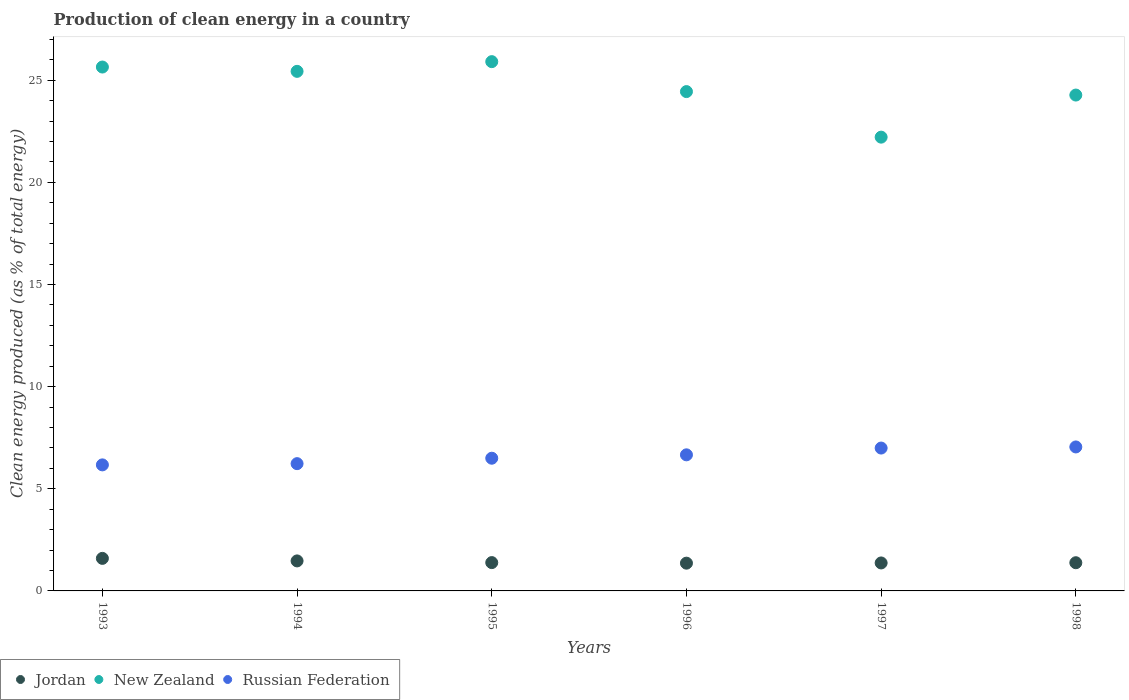What is the percentage of clean energy produced in New Zealand in 1994?
Give a very brief answer. 25.44. Across all years, what is the maximum percentage of clean energy produced in Jordan?
Provide a succinct answer. 1.59. Across all years, what is the minimum percentage of clean energy produced in Jordan?
Your response must be concise. 1.36. In which year was the percentage of clean energy produced in New Zealand minimum?
Give a very brief answer. 1997. What is the total percentage of clean energy produced in Jordan in the graph?
Your answer should be very brief. 8.56. What is the difference between the percentage of clean energy produced in Russian Federation in 1995 and that in 1997?
Provide a short and direct response. -0.5. What is the difference between the percentage of clean energy produced in New Zealand in 1998 and the percentage of clean energy produced in Jordan in 1997?
Your answer should be very brief. 22.91. What is the average percentage of clean energy produced in Russian Federation per year?
Offer a very short reply. 6.6. In the year 1998, what is the difference between the percentage of clean energy produced in Jordan and percentage of clean energy produced in Russian Federation?
Make the answer very short. -5.67. What is the ratio of the percentage of clean energy produced in Jordan in 1993 to that in 1998?
Your answer should be compact. 1.15. Is the difference between the percentage of clean energy produced in Jordan in 1993 and 1994 greater than the difference between the percentage of clean energy produced in Russian Federation in 1993 and 1994?
Make the answer very short. Yes. What is the difference between the highest and the second highest percentage of clean energy produced in New Zealand?
Your response must be concise. 0.26. What is the difference between the highest and the lowest percentage of clean energy produced in Jordan?
Make the answer very short. 0.23. Is the sum of the percentage of clean energy produced in New Zealand in 1994 and 1997 greater than the maximum percentage of clean energy produced in Jordan across all years?
Provide a short and direct response. Yes. Is it the case that in every year, the sum of the percentage of clean energy produced in New Zealand and percentage of clean energy produced in Jordan  is greater than the percentage of clean energy produced in Russian Federation?
Provide a short and direct response. Yes. Is the percentage of clean energy produced in New Zealand strictly less than the percentage of clean energy produced in Russian Federation over the years?
Provide a succinct answer. No. How many dotlines are there?
Make the answer very short. 3. Where does the legend appear in the graph?
Give a very brief answer. Bottom left. How are the legend labels stacked?
Ensure brevity in your answer.  Horizontal. What is the title of the graph?
Make the answer very short. Production of clean energy in a country. What is the label or title of the X-axis?
Provide a short and direct response. Years. What is the label or title of the Y-axis?
Make the answer very short. Clean energy produced (as % of total energy). What is the Clean energy produced (as % of total energy) of Jordan in 1993?
Your answer should be compact. 1.59. What is the Clean energy produced (as % of total energy) of New Zealand in 1993?
Ensure brevity in your answer.  25.65. What is the Clean energy produced (as % of total energy) in Russian Federation in 1993?
Give a very brief answer. 6.17. What is the Clean energy produced (as % of total energy) in Jordan in 1994?
Offer a very short reply. 1.47. What is the Clean energy produced (as % of total energy) in New Zealand in 1994?
Ensure brevity in your answer.  25.44. What is the Clean energy produced (as % of total energy) in Russian Federation in 1994?
Provide a short and direct response. 6.23. What is the Clean energy produced (as % of total energy) of Jordan in 1995?
Provide a short and direct response. 1.39. What is the Clean energy produced (as % of total energy) of New Zealand in 1995?
Provide a short and direct response. 25.91. What is the Clean energy produced (as % of total energy) of Russian Federation in 1995?
Provide a succinct answer. 6.5. What is the Clean energy produced (as % of total energy) of Jordan in 1996?
Your answer should be compact. 1.36. What is the Clean energy produced (as % of total energy) in New Zealand in 1996?
Provide a succinct answer. 24.45. What is the Clean energy produced (as % of total energy) of Russian Federation in 1996?
Give a very brief answer. 6.66. What is the Clean energy produced (as % of total energy) of Jordan in 1997?
Your answer should be very brief. 1.37. What is the Clean energy produced (as % of total energy) in New Zealand in 1997?
Your answer should be very brief. 22.22. What is the Clean energy produced (as % of total energy) in Russian Federation in 1997?
Provide a succinct answer. 6.99. What is the Clean energy produced (as % of total energy) in Jordan in 1998?
Offer a very short reply. 1.38. What is the Clean energy produced (as % of total energy) of New Zealand in 1998?
Your response must be concise. 24.28. What is the Clean energy produced (as % of total energy) in Russian Federation in 1998?
Provide a short and direct response. 7.05. Across all years, what is the maximum Clean energy produced (as % of total energy) of Jordan?
Provide a succinct answer. 1.59. Across all years, what is the maximum Clean energy produced (as % of total energy) in New Zealand?
Your answer should be compact. 25.91. Across all years, what is the maximum Clean energy produced (as % of total energy) of Russian Federation?
Ensure brevity in your answer.  7.05. Across all years, what is the minimum Clean energy produced (as % of total energy) of Jordan?
Provide a succinct answer. 1.36. Across all years, what is the minimum Clean energy produced (as % of total energy) in New Zealand?
Your response must be concise. 22.22. Across all years, what is the minimum Clean energy produced (as % of total energy) of Russian Federation?
Make the answer very short. 6.17. What is the total Clean energy produced (as % of total energy) in Jordan in the graph?
Keep it short and to the point. 8.56. What is the total Clean energy produced (as % of total energy) of New Zealand in the graph?
Provide a short and direct response. 147.93. What is the total Clean energy produced (as % of total energy) of Russian Federation in the graph?
Keep it short and to the point. 39.6. What is the difference between the Clean energy produced (as % of total energy) of Jordan in 1993 and that in 1994?
Provide a short and direct response. 0.12. What is the difference between the Clean energy produced (as % of total energy) of New Zealand in 1993 and that in 1994?
Your response must be concise. 0.21. What is the difference between the Clean energy produced (as % of total energy) of Russian Federation in 1993 and that in 1994?
Ensure brevity in your answer.  -0.06. What is the difference between the Clean energy produced (as % of total energy) of Jordan in 1993 and that in 1995?
Ensure brevity in your answer.  0.21. What is the difference between the Clean energy produced (as % of total energy) of New Zealand in 1993 and that in 1995?
Keep it short and to the point. -0.26. What is the difference between the Clean energy produced (as % of total energy) of Russian Federation in 1993 and that in 1995?
Ensure brevity in your answer.  -0.33. What is the difference between the Clean energy produced (as % of total energy) in Jordan in 1993 and that in 1996?
Give a very brief answer. 0.23. What is the difference between the Clean energy produced (as % of total energy) in New Zealand in 1993 and that in 1996?
Ensure brevity in your answer.  1.2. What is the difference between the Clean energy produced (as % of total energy) in Russian Federation in 1993 and that in 1996?
Make the answer very short. -0.49. What is the difference between the Clean energy produced (as % of total energy) of Jordan in 1993 and that in 1997?
Provide a short and direct response. 0.22. What is the difference between the Clean energy produced (as % of total energy) of New Zealand in 1993 and that in 1997?
Ensure brevity in your answer.  3.43. What is the difference between the Clean energy produced (as % of total energy) of Russian Federation in 1993 and that in 1997?
Keep it short and to the point. -0.82. What is the difference between the Clean energy produced (as % of total energy) in Jordan in 1993 and that in 1998?
Your response must be concise. 0.21. What is the difference between the Clean energy produced (as % of total energy) in New Zealand in 1993 and that in 1998?
Your answer should be very brief. 1.37. What is the difference between the Clean energy produced (as % of total energy) in Russian Federation in 1993 and that in 1998?
Provide a succinct answer. -0.88. What is the difference between the Clean energy produced (as % of total energy) in Jordan in 1994 and that in 1995?
Offer a terse response. 0.08. What is the difference between the Clean energy produced (as % of total energy) of New Zealand in 1994 and that in 1995?
Give a very brief answer. -0.47. What is the difference between the Clean energy produced (as % of total energy) in Russian Federation in 1994 and that in 1995?
Provide a short and direct response. -0.27. What is the difference between the Clean energy produced (as % of total energy) in Jordan in 1994 and that in 1996?
Your response must be concise. 0.11. What is the difference between the Clean energy produced (as % of total energy) of Russian Federation in 1994 and that in 1996?
Offer a very short reply. -0.43. What is the difference between the Clean energy produced (as % of total energy) in New Zealand in 1994 and that in 1997?
Provide a short and direct response. 3.22. What is the difference between the Clean energy produced (as % of total energy) in Russian Federation in 1994 and that in 1997?
Ensure brevity in your answer.  -0.76. What is the difference between the Clean energy produced (as % of total energy) in Jordan in 1994 and that in 1998?
Your answer should be very brief. 0.09. What is the difference between the Clean energy produced (as % of total energy) in New Zealand in 1994 and that in 1998?
Keep it short and to the point. 1.16. What is the difference between the Clean energy produced (as % of total energy) in Russian Federation in 1994 and that in 1998?
Offer a terse response. -0.82. What is the difference between the Clean energy produced (as % of total energy) in Jordan in 1995 and that in 1996?
Keep it short and to the point. 0.03. What is the difference between the Clean energy produced (as % of total energy) of New Zealand in 1995 and that in 1996?
Your answer should be compact. 1.47. What is the difference between the Clean energy produced (as % of total energy) of Russian Federation in 1995 and that in 1996?
Your answer should be compact. -0.17. What is the difference between the Clean energy produced (as % of total energy) in Jordan in 1995 and that in 1997?
Give a very brief answer. 0.02. What is the difference between the Clean energy produced (as % of total energy) of New Zealand in 1995 and that in 1997?
Keep it short and to the point. 3.7. What is the difference between the Clean energy produced (as % of total energy) of Russian Federation in 1995 and that in 1997?
Offer a terse response. -0.5. What is the difference between the Clean energy produced (as % of total energy) in Jordan in 1995 and that in 1998?
Keep it short and to the point. 0.01. What is the difference between the Clean energy produced (as % of total energy) of New Zealand in 1995 and that in 1998?
Offer a very short reply. 1.64. What is the difference between the Clean energy produced (as % of total energy) in Russian Federation in 1995 and that in 1998?
Provide a succinct answer. -0.55. What is the difference between the Clean energy produced (as % of total energy) in Jordan in 1996 and that in 1997?
Make the answer very short. -0.01. What is the difference between the Clean energy produced (as % of total energy) in New Zealand in 1996 and that in 1997?
Make the answer very short. 2.23. What is the difference between the Clean energy produced (as % of total energy) of Russian Federation in 1996 and that in 1997?
Make the answer very short. -0.33. What is the difference between the Clean energy produced (as % of total energy) of Jordan in 1996 and that in 1998?
Provide a succinct answer. -0.02. What is the difference between the Clean energy produced (as % of total energy) in New Zealand in 1996 and that in 1998?
Your response must be concise. 0.17. What is the difference between the Clean energy produced (as % of total energy) of Russian Federation in 1996 and that in 1998?
Your response must be concise. -0.39. What is the difference between the Clean energy produced (as % of total energy) of Jordan in 1997 and that in 1998?
Your answer should be very brief. -0.01. What is the difference between the Clean energy produced (as % of total energy) of New Zealand in 1997 and that in 1998?
Ensure brevity in your answer.  -2.06. What is the difference between the Clean energy produced (as % of total energy) of Russian Federation in 1997 and that in 1998?
Your answer should be very brief. -0.05. What is the difference between the Clean energy produced (as % of total energy) of Jordan in 1993 and the Clean energy produced (as % of total energy) of New Zealand in 1994?
Keep it short and to the point. -23.84. What is the difference between the Clean energy produced (as % of total energy) in Jordan in 1993 and the Clean energy produced (as % of total energy) in Russian Federation in 1994?
Provide a short and direct response. -4.64. What is the difference between the Clean energy produced (as % of total energy) in New Zealand in 1993 and the Clean energy produced (as % of total energy) in Russian Federation in 1994?
Keep it short and to the point. 19.42. What is the difference between the Clean energy produced (as % of total energy) in Jordan in 1993 and the Clean energy produced (as % of total energy) in New Zealand in 1995?
Offer a terse response. -24.32. What is the difference between the Clean energy produced (as % of total energy) of Jordan in 1993 and the Clean energy produced (as % of total energy) of Russian Federation in 1995?
Give a very brief answer. -4.9. What is the difference between the Clean energy produced (as % of total energy) in New Zealand in 1993 and the Clean energy produced (as % of total energy) in Russian Federation in 1995?
Make the answer very short. 19.15. What is the difference between the Clean energy produced (as % of total energy) in Jordan in 1993 and the Clean energy produced (as % of total energy) in New Zealand in 1996?
Your answer should be very brief. -22.85. What is the difference between the Clean energy produced (as % of total energy) of Jordan in 1993 and the Clean energy produced (as % of total energy) of Russian Federation in 1996?
Give a very brief answer. -5.07. What is the difference between the Clean energy produced (as % of total energy) of New Zealand in 1993 and the Clean energy produced (as % of total energy) of Russian Federation in 1996?
Offer a very short reply. 18.99. What is the difference between the Clean energy produced (as % of total energy) of Jordan in 1993 and the Clean energy produced (as % of total energy) of New Zealand in 1997?
Make the answer very short. -20.62. What is the difference between the Clean energy produced (as % of total energy) of Jordan in 1993 and the Clean energy produced (as % of total energy) of Russian Federation in 1997?
Provide a short and direct response. -5.4. What is the difference between the Clean energy produced (as % of total energy) in New Zealand in 1993 and the Clean energy produced (as % of total energy) in Russian Federation in 1997?
Keep it short and to the point. 18.65. What is the difference between the Clean energy produced (as % of total energy) of Jordan in 1993 and the Clean energy produced (as % of total energy) of New Zealand in 1998?
Make the answer very short. -22.68. What is the difference between the Clean energy produced (as % of total energy) of Jordan in 1993 and the Clean energy produced (as % of total energy) of Russian Federation in 1998?
Your answer should be compact. -5.45. What is the difference between the Clean energy produced (as % of total energy) of New Zealand in 1993 and the Clean energy produced (as % of total energy) of Russian Federation in 1998?
Give a very brief answer. 18.6. What is the difference between the Clean energy produced (as % of total energy) of Jordan in 1994 and the Clean energy produced (as % of total energy) of New Zealand in 1995?
Your answer should be compact. -24.44. What is the difference between the Clean energy produced (as % of total energy) of Jordan in 1994 and the Clean energy produced (as % of total energy) of Russian Federation in 1995?
Provide a short and direct response. -5.03. What is the difference between the Clean energy produced (as % of total energy) of New Zealand in 1994 and the Clean energy produced (as % of total energy) of Russian Federation in 1995?
Provide a succinct answer. 18.94. What is the difference between the Clean energy produced (as % of total energy) of Jordan in 1994 and the Clean energy produced (as % of total energy) of New Zealand in 1996?
Keep it short and to the point. -22.98. What is the difference between the Clean energy produced (as % of total energy) of Jordan in 1994 and the Clean energy produced (as % of total energy) of Russian Federation in 1996?
Give a very brief answer. -5.19. What is the difference between the Clean energy produced (as % of total energy) in New Zealand in 1994 and the Clean energy produced (as % of total energy) in Russian Federation in 1996?
Offer a very short reply. 18.77. What is the difference between the Clean energy produced (as % of total energy) in Jordan in 1994 and the Clean energy produced (as % of total energy) in New Zealand in 1997?
Make the answer very short. -20.75. What is the difference between the Clean energy produced (as % of total energy) in Jordan in 1994 and the Clean energy produced (as % of total energy) in Russian Federation in 1997?
Give a very brief answer. -5.52. What is the difference between the Clean energy produced (as % of total energy) in New Zealand in 1994 and the Clean energy produced (as % of total energy) in Russian Federation in 1997?
Keep it short and to the point. 18.44. What is the difference between the Clean energy produced (as % of total energy) in Jordan in 1994 and the Clean energy produced (as % of total energy) in New Zealand in 1998?
Keep it short and to the point. -22.81. What is the difference between the Clean energy produced (as % of total energy) of Jordan in 1994 and the Clean energy produced (as % of total energy) of Russian Federation in 1998?
Provide a succinct answer. -5.58. What is the difference between the Clean energy produced (as % of total energy) in New Zealand in 1994 and the Clean energy produced (as % of total energy) in Russian Federation in 1998?
Your response must be concise. 18.39. What is the difference between the Clean energy produced (as % of total energy) in Jordan in 1995 and the Clean energy produced (as % of total energy) in New Zealand in 1996?
Offer a very short reply. -23.06. What is the difference between the Clean energy produced (as % of total energy) in Jordan in 1995 and the Clean energy produced (as % of total energy) in Russian Federation in 1996?
Keep it short and to the point. -5.28. What is the difference between the Clean energy produced (as % of total energy) in New Zealand in 1995 and the Clean energy produced (as % of total energy) in Russian Federation in 1996?
Provide a succinct answer. 19.25. What is the difference between the Clean energy produced (as % of total energy) in Jordan in 1995 and the Clean energy produced (as % of total energy) in New Zealand in 1997?
Provide a short and direct response. -20.83. What is the difference between the Clean energy produced (as % of total energy) in Jordan in 1995 and the Clean energy produced (as % of total energy) in Russian Federation in 1997?
Keep it short and to the point. -5.61. What is the difference between the Clean energy produced (as % of total energy) of New Zealand in 1995 and the Clean energy produced (as % of total energy) of Russian Federation in 1997?
Your answer should be very brief. 18.92. What is the difference between the Clean energy produced (as % of total energy) in Jordan in 1995 and the Clean energy produced (as % of total energy) in New Zealand in 1998?
Make the answer very short. -22.89. What is the difference between the Clean energy produced (as % of total energy) in Jordan in 1995 and the Clean energy produced (as % of total energy) in Russian Federation in 1998?
Offer a terse response. -5.66. What is the difference between the Clean energy produced (as % of total energy) in New Zealand in 1995 and the Clean energy produced (as % of total energy) in Russian Federation in 1998?
Your response must be concise. 18.86. What is the difference between the Clean energy produced (as % of total energy) of Jordan in 1996 and the Clean energy produced (as % of total energy) of New Zealand in 1997?
Offer a very short reply. -20.86. What is the difference between the Clean energy produced (as % of total energy) of Jordan in 1996 and the Clean energy produced (as % of total energy) of Russian Federation in 1997?
Offer a very short reply. -5.64. What is the difference between the Clean energy produced (as % of total energy) of New Zealand in 1996 and the Clean energy produced (as % of total energy) of Russian Federation in 1997?
Keep it short and to the point. 17.45. What is the difference between the Clean energy produced (as % of total energy) in Jordan in 1996 and the Clean energy produced (as % of total energy) in New Zealand in 1998?
Your answer should be compact. -22.92. What is the difference between the Clean energy produced (as % of total energy) in Jordan in 1996 and the Clean energy produced (as % of total energy) in Russian Federation in 1998?
Make the answer very short. -5.69. What is the difference between the Clean energy produced (as % of total energy) of New Zealand in 1996 and the Clean energy produced (as % of total energy) of Russian Federation in 1998?
Give a very brief answer. 17.4. What is the difference between the Clean energy produced (as % of total energy) in Jordan in 1997 and the Clean energy produced (as % of total energy) in New Zealand in 1998?
Your response must be concise. -22.91. What is the difference between the Clean energy produced (as % of total energy) of Jordan in 1997 and the Clean energy produced (as % of total energy) of Russian Federation in 1998?
Provide a short and direct response. -5.68. What is the difference between the Clean energy produced (as % of total energy) of New Zealand in 1997 and the Clean energy produced (as % of total energy) of Russian Federation in 1998?
Ensure brevity in your answer.  15.17. What is the average Clean energy produced (as % of total energy) in Jordan per year?
Keep it short and to the point. 1.43. What is the average Clean energy produced (as % of total energy) of New Zealand per year?
Offer a terse response. 24.66. What is the average Clean energy produced (as % of total energy) of Russian Federation per year?
Your answer should be compact. 6.6. In the year 1993, what is the difference between the Clean energy produced (as % of total energy) of Jordan and Clean energy produced (as % of total energy) of New Zealand?
Your response must be concise. -24.05. In the year 1993, what is the difference between the Clean energy produced (as % of total energy) in Jordan and Clean energy produced (as % of total energy) in Russian Federation?
Offer a terse response. -4.58. In the year 1993, what is the difference between the Clean energy produced (as % of total energy) of New Zealand and Clean energy produced (as % of total energy) of Russian Federation?
Give a very brief answer. 19.48. In the year 1994, what is the difference between the Clean energy produced (as % of total energy) of Jordan and Clean energy produced (as % of total energy) of New Zealand?
Offer a very short reply. -23.97. In the year 1994, what is the difference between the Clean energy produced (as % of total energy) in Jordan and Clean energy produced (as % of total energy) in Russian Federation?
Give a very brief answer. -4.76. In the year 1994, what is the difference between the Clean energy produced (as % of total energy) of New Zealand and Clean energy produced (as % of total energy) of Russian Federation?
Your response must be concise. 19.21. In the year 1995, what is the difference between the Clean energy produced (as % of total energy) in Jordan and Clean energy produced (as % of total energy) in New Zealand?
Provide a short and direct response. -24.52. In the year 1995, what is the difference between the Clean energy produced (as % of total energy) in Jordan and Clean energy produced (as % of total energy) in Russian Federation?
Offer a terse response. -5.11. In the year 1995, what is the difference between the Clean energy produced (as % of total energy) in New Zealand and Clean energy produced (as % of total energy) in Russian Federation?
Keep it short and to the point. 19.41. In the year 1996, what is the difference between the Clean energy produced (as % of total energy) in Jordan and Clean energy produced (as % of total energy) in New Zealand?
Offer a very short reply. -23.09. In the year 1996, what is the difference between the Clean energy produced (as % of total energy) in Jordan and Clean energy produced (as % of total energy) in Russian Federation?
Provide a short and direct response. -5.3. In the year 1996, what is the difference between the Clean energy produced (as % of total energy) in New Zealand and Clean energy produced (as % of total energy) in Russian Federation?
Ensure brevity in your answer.  17.78. In the year 1997, what is the difference between the Clean energy produced (as % of total energy) in Jordan and Clean energy produced (as % of total energy) in New Zealand?
Your answer should be very brief. -20.85. In the year 1997, what is the difference between the Clean energy produced (as % of total energy) in Jordan and Clean energy produced (as % of total energy) in Russian Federation?
Your response must be concise. -5.62. In the year 1997, what is the difference between the Clean energy produced (as % of total energy) of New Zealand and Clean energy produced (as % of total energy) of Russian Federation?
Your answer should be compact. 15.22. In the year 1998, what is the difference between the Clean energy produced (as % of total energy) in Jordan and Clean energy produced (as % of total energy) in New Zealand?
Offer a very short reply. -22.9. In the year 1998, what is the difference between the Clean energy produced (as % of total energy) in Jordan and Clean energy produced (as % of total energy) in Russian Federation?
Keep it short and to the point. -5.67. In the year 1998, what is the difference between the Clean energy produced (as % of total energy) in New Zealand and Clean energy produced (as % of total energy) in Russian Federation?
Provide a short and direct response. 17.23. What is the ratio of the Clean energy produced (as % of total energy) of Jordan in 1993 to that in 1994?
Provide a short and direct response. 1.08. What is the ratio of the Clean energy produced (as % of total energy) of New Zealand in 1993 to that in 1994?
Make the answer very short. 1.01. What is the ratio of the Clean energy produced (as % of total energy) of Russian Federation in 1993 to that in 1994?
Offer a very short reply. 0.99. What is the ratio of the Clean energy produced (as % of total energy) in Jordan in 1993 to that in 1995?
Your answer should be very brief. 1.15. What is the ratio of the Clean energy produced (as % of total energy) of Russian Federation in 1993 to that in 1995?
Your answer should be compact. 0.95. What is the ratio of the Clean energy produced (as % of total energy) of Jordan in 1993 to that in 1996?
Your answer should be very brief. 1.17. What is the ratio of the Clean energy produced (as % of total energy) of New Zealand in 1993 to that in 1996?
Provide a succinct answer. 1.05. What is the ratio of the Clean energy produced (as % of total energy) in Russian Federation in 1993 to that in 1996?
Offer a very short reply. 0.93. What is the ratio of the Clean energy produced (as % of total energy) in Jordan in 1993 to that in 1997?
Your answer should be compact. 1.16. What is the ratio of the Clean energy produced (as % of total energy) of New Zealand in 1993 to that in 1997?
Your response must be concise. 1.15. What is the ratio of the Clean energy produced (as % of total energy) of Russian Federation in 1993 to that in 1997?
Your answer should be compact. 0.88. What is the ratio of the Clean energy produced (as % of total energy) in Jordan in 1993 to that in 1998?
Provide a succinct answer. 1.15. What is the ratio of the Clean energy produced (as % of total energy) of New Zealand in 1993 to that in 1998?
Your response must be concise. 1.06. What is the ratio of the Clean energy produced (as % of total energy) of Russian Federation in 1993 to that in 1998?
Make the answer very short. 0.88. What is the ratio of the Clean energy produced (as % of total energy) of Jordan in 1994 to that in 1995?
Offer a terse response. 1.06. What is the ratio of the Clean energy produced (as % of total energy) of New Zealand in 1994 to that in 1995?
Your answer should be compact. 0.98. What is the ratio of the Clean energy produced (as % of total energy) of Russian Federation in 1994 to that in 1995?
Offer a very short reply. 0.96. What is the ratio of the Clean energy produced (as % of total energy) of Jordan in 1994 to that in 1996?
Offer a very short reply. 1.08. What is the ratio of the Clean energy produced (as % of total energy) in New Zealand in 1994 to that in 1996?
Keep it short and to the point. 1.04. What is the ratio of the Clean energy produced (as % of total energy) of Russian Federation in 1994 to that in 1996?
Make the answer very short. 0.94. What is the ratio of the Clean energy produced (as % of total energy) in Jordan in 1994 to that in 1997?
Offer a terse response. 1.07. What is the ratio of the Clean energy produced (as % of total energy) of New Zealand in 1994 to that in 1997?
Offer a very short reply. 1.15. What is the ratio of the Clean energy produced (as % of total energy) in Russian Federation in 1994 to that in 1997?
Offer a very short reply. 0.89. What is the ratio of the Clean energy produced (as % of total energy) of Jordan in 1994 to that in 1998?
Ensure brevity in your answer.  1.06. What is the ratio of the Clean energy produced (as % of total energy) of New Zealand in 1994 to that in 1998?
Make the answer very short. 1.05. What is the ratio of the Clean energy produced (as % of total energy) of Russian Federation in 1994 to that in 1998?
Offer a very short reply. 0.88. What is the ratio of the Clean energy produced (as % of total energy) of Jordan in 1995 to that in 1996?
Your response must be concise. 1.02. What is the ratio of the Clean energy produced (as % of total energy) in New Zealand in 1995 to that in 1996?
Ensure brevity in your answer.  1.06. What is the ratio of the Clean energy produced (as % of total energy) of Russian Federation in 1995 to that in 1996?
Your answer should be compact. 0.98. What is the ratio of the Clean energy produced (as % of total energy) in Jordan in 1995 to that in 1997?
Your answer should be very brief. 1.01. What is the ratio of the Clean energy produced (as % of total energy) of New Zealand in 1995 to that in 1997?
Make the answer very short. 1.17. What is the ratio of the Clean energy produced (as % of total energy) of Russian Federation in 1995 to that in 1997?
Keep it short and to the point. 0.93. What is the ratio of the Clean energy produced (as % of total energy) of Jordan in 1995 to that in 1998?
Your answer should be very brief. 1. What is the ratio of the Clean energy produced (as % of total energy) of New Zealand in 1995 to that in 1998?
Offer a very short reply. 1.07. What is the ratio of the Clean energy produced (as % of total energy) in Russian Federation in 1995 to that in 1998?
Your answer should be compact. 0.92. What is the ratio of the Clean energy produced (as % of total energy) of Jordan in 1996 to that in 1997?
Offer a terse response. 0.99. What is the ratio of the Clean energy produced (as % of total energy) of New Zealand in 1996 to that in 1997?
Your answer should be compact. 1.1. What is the ratio of the Clean energy produced (as % of total energy) of Russian Federation in 1996 to that in 1997?
Offer a very short reply. 0.95. What is the ratio of the Clean energy produced (as % of total energy) in Jordan in 1996 to that in 1998?
Offer a very short reply. 0.98. What is the ratio of the Clean energy produced (as % of total energy) of Russian Federation in 1996 to that in 1998?
Offer a very short reply. 0.95. What is the ratio of the Clean energy produced (as % of total energy) in Jordan in 1997 to that in 1998?
Provide a succinct answer. 0.99. What is the ratio of the Clean energy produced (as % of total energy) of New Zealand in 1997 to that in 1998?
Offer a very short reply. 0.92. What is the difference between the highest and the second highest Clean energy produced (as % of total energy) in Jordan?
Offer a very short reply. 0.12. What is the difference between the highest and the second highest Clean energy produced (as % of total energy) of New Zealand?
Provide a succinct answer. 0.26. What is the difference between the highest and the second highest Clean energy produced (as % of total energy) in Russian Federation?
Keep it short and to the point. 0.05. What is the difference between the highest and the lowest Clean energy produced (as % of total energy) of Jordan?
Ensure brevity in your answer.  0.23. What is the difference between the highest and the lowest Clean energy produced (as % of total energy) of New Zealand?
Keep it short and to the point. 3.7. What is the difference between the highest and the lowest Clean energy produced (as % of total energy) in Russian Federation?
Your answer should be very brief. 0.88. 